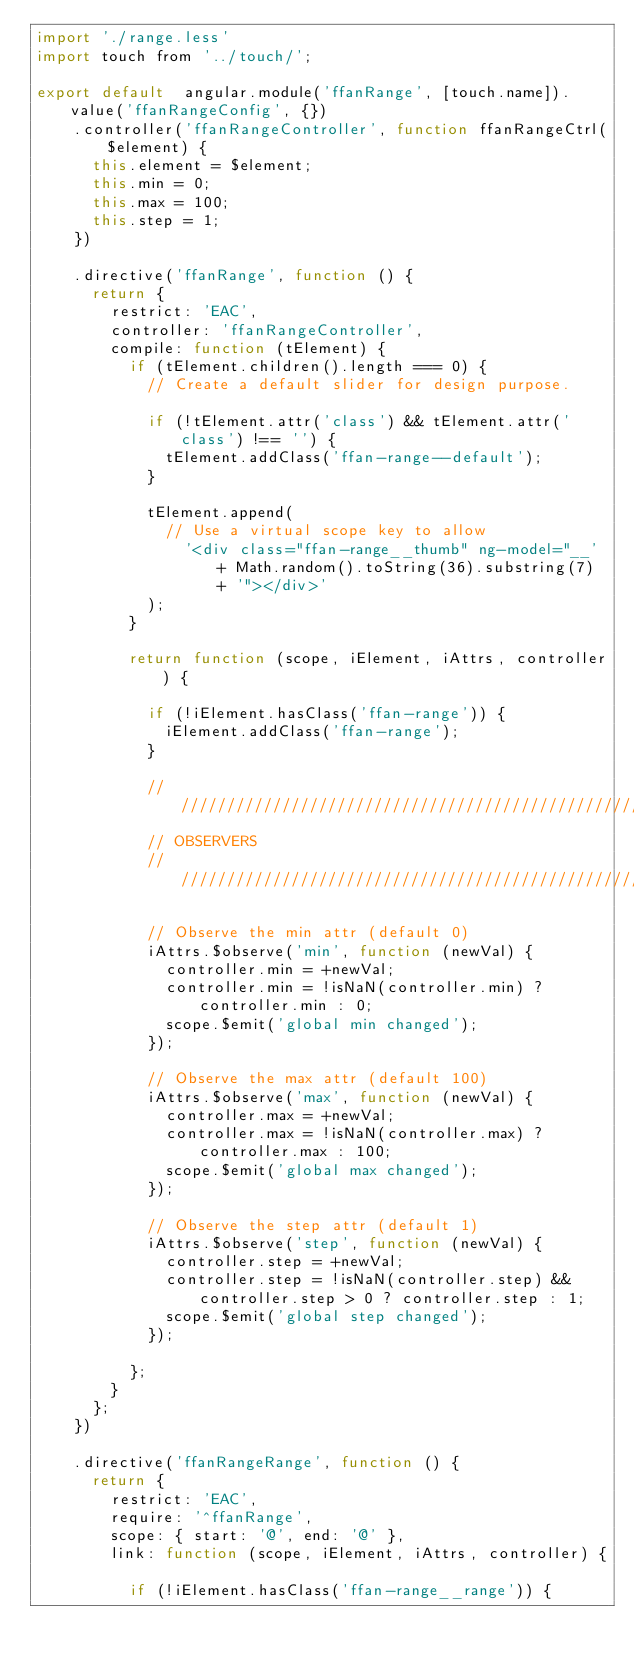Convert code to text. <code><loc_0><loc_0><loc_500><loc_500><_JavaScript_>import './range.less'
import touch from '../touch/';

export default  angular.module('ffanRange', [touch.name]).value('ffanRangeConfig', {})
    .controller('ffanRangeController', function ffanRangeCtrl($element) {
      this.element = $element;
      this.min = 0;
      this.max = 100;
      this.step = 1;
    })
	  
    .directive('ffanRange', function () {
      return {
        restrict: 'EAC',
        controller: 'ffanRangeController',
        compile: function (tElement) {
          if (tElement.children().length === 0) {
            // Create a default slider for design purpose.

            if (!tElement.attr('class') && tElement.attr('class') !== '') {
              tElement.addClass('ffan-range--default');
            }

            tElement.append(
              // Use a virtual scope key to allow
                '<div class="ffan-range__thumb" ng-model="__' + Math.random().toString(36).substring(7) + '"></div>' 
            );
          }

          return function (scope, iElement, iAttrs, controller) {

            if (!iElement.hasClass('ffan-range')) {
              iElement.addClass('ffan-range');
            }

            ////////////////////////////////////////////////////////////////////
            // OBSERVERS
            ////////////////////////////////////////////////////////////////////

            // Observe the min attr (default 0)
            iAttrs.$observe('min', function (newVal) {
              controller.min = +newVal;
              controller.min = !isNaN(controller.min) ? controller.min : 0;
              scope.$emit('global min changed');
            });

            // Observe the max attr (default 100)
            iAttrs.$observe('max', function (newVal) {
              controller.max = +newVal;
              controller.max = !isNaN(controller.max) ? controller.max : 100;
              scope.$emit('global max changed');
            });

            // Observe the step attr (default 1)
            iAttrs.$observe('step', function (newVal) {
              controller.step = +newVal;
              controller.step = !isNaN(controller.step) && controller.step > 0 ? controller.step : 1;
              scope.$emit('global step changed');
            });

          };
        }
      };
    })

    .directive('ffanRangeRange', function () {
      return {
        restrict: 'EAC',
        require: '^ffanRange',
        scope: { start: '@', end: '@' },
        link: function (scope, iElement, iAttrs, controller) {

          if (!iElement.hasClass('ffan-range__range')) {</code> 